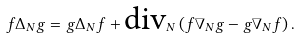Convert formula to latex. <formula><loc_0><loc_0><loc_500><loc_500>f \Delta _ { N } g = g \Delta _ { N } f + \text {div} _ { N } \left ( f \nabla _ { N } g - g \nabla _ { N } f \right ) .</formula> 